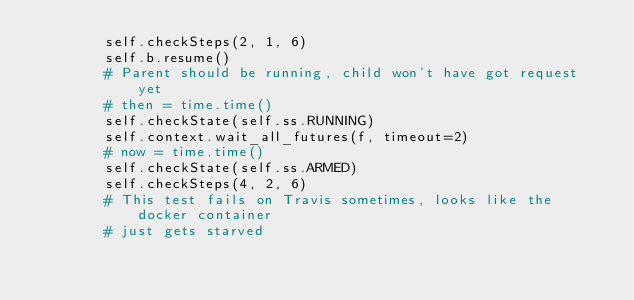Convert code to text. <code><loc_0><loc_0><loc_500><loc_500><_Python_>        self.checkSteps(2, 1, 6)
        self.b.resume()
        # Parent should be running, child won't have got request yet
        # then = time.time()
        self.checkState(self.ss.RUNNING)
        self.context.wait_all_futures(f, timeout=2)
        # now = time.time()
        self.checkState(self.ss.ARMED)
        self.checkSteps(4, 2, 6)
        # This test fails on Travis sometimes, looks like the docker container
        # just gets starved</code> 